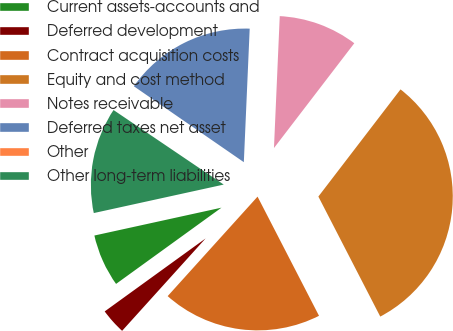<chart> <loc_0><loc_0><loc_500><loc_500><pie_chart><fcel>Current assets-accounts and<fcel>Deferred development<fcel>Contract acquisition costs<fcel>Equity and cost method<fcel>Notes receivable<fcel>Deferred taxes net asset<fcel>Other<fcel>Other long-term liabilities<nl><fcel>6.53%<fcel>3.34%<fcel>19.27%<fcel>32.01%<fcel>9.71%<fcel>16.08%<fcel>0.15%<fcel>12.9%<nl></chart> 